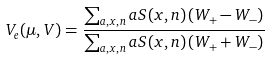<formula> <loc_0><loc_0><loc_500><loc_500>V _ { e } ( \mu , V ) = \frac { \sum _ { a , x , n } a S ( x , n ) \left ( W _ { + } - W _ { - } \right ) } { \sum _ { a , x , n } a S ( x , n ) \left ( W _ { + } + W _ { - } \right ) }</formula> 